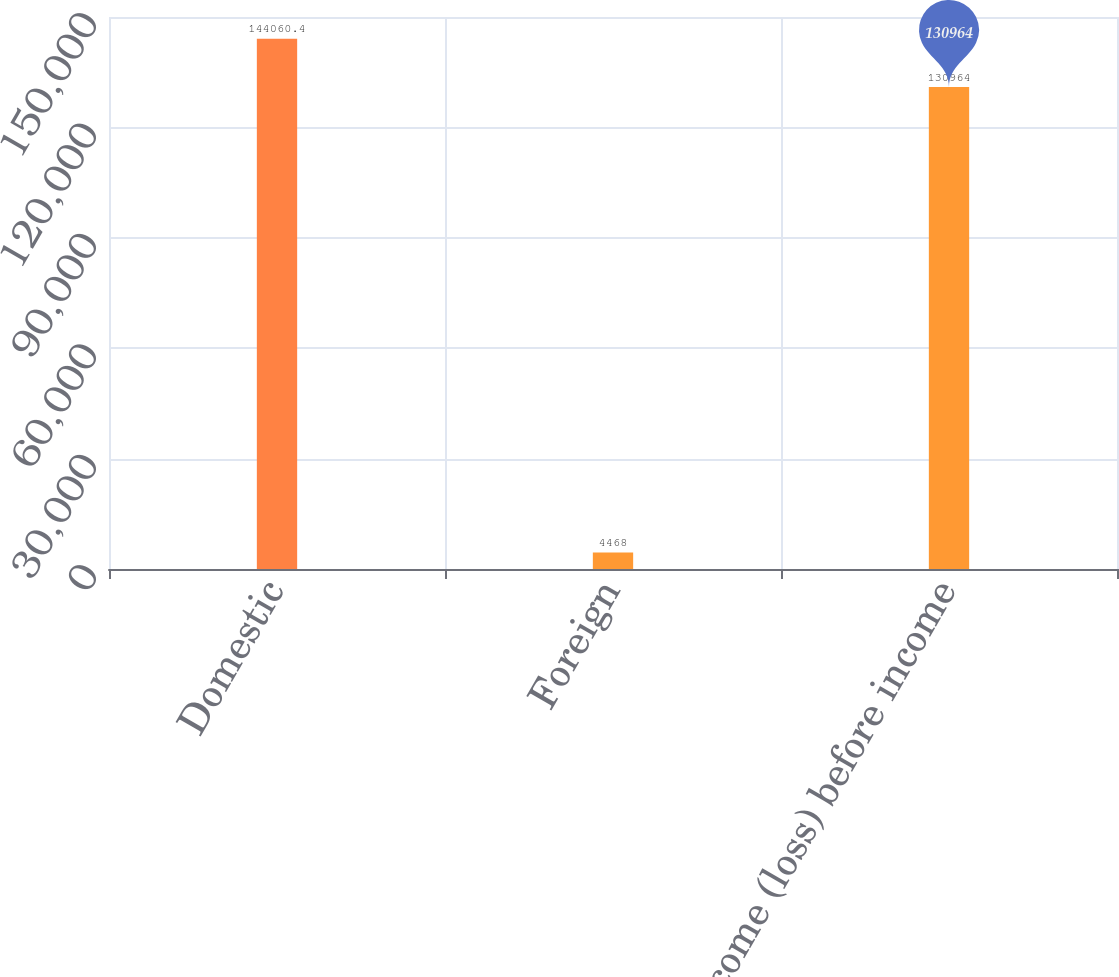Convert chart to OTSL. <chart><loc_0><loc_0><loc_500><loc_500><bar_chart><fcel>Domestic<fcel>Foreign<fcel>Income (loss) before income<nl><fcel>144060<fcel>4468<fcel>130964<nl></chart> 